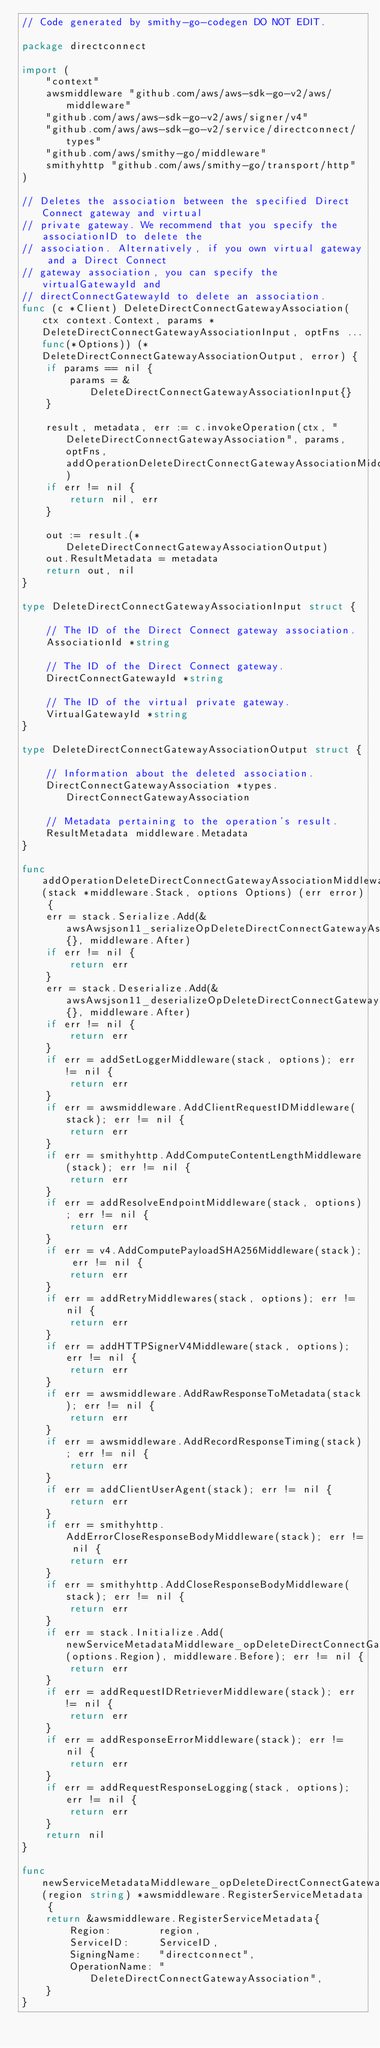Convert code to text. <code><loc_0><loc_0><loc_500><loc_500><_Go_>// Code generated by smithy-go-codegen DO NOT EDIT.

package directconnect

import (
	"context"
	awsmiddleware "github.com/aws/aws-sdk-go-v2/aws/middleware"
	"github.com/aws/aws-sdk-go-v2/aws/signer/v4"
	"github.com/aws/aws-sdk-go-v2/service/directconnect/types"
	"github.com/aws/smithy-go/middleware"
	smithyhttp "github.com/aws/smithy-go/transport/http"
)

// Deletes the association between the specified Direct Connect gateway and virtual
// private gateway. We recommend that you specify the associationID to delete the
// association. Alternatively, if you own virtual gateway and a Direct Connect
// gateway association, you can specify the virtualGatewayId and
// directConnectGatewayId to delete an association.
func (c *Client) DeleteDirectConnectGatewayAssociation(ctx context.Context, params *DeleteDirectConnectGatewayAssociationInput, optFns ...func(*Options)) (*DeleteDirectConnectGatewayAssociationOutput, error) {
	if params == nil {
		params = &DeleteDirectConnectGatewayAssociationInput{}
	}

	result, metadata, err := c.invokeOperation(ctx, "DeleteDirectConnectGatewayAssociation", params, optFns, addOperationDeleteDirectConnectGatewayAssociationMiddlewares)
	if err != nil {
		return nil, err
	}

	out := result.(*DeleteDirectConnectGatewayAssociationOutput)
	out.ResultMetadata = metadata
	return out, nil
}

type DeleteDirectConnectGatewayAssociationInput struct {

	// The ID of the Direct Connect gateway association.
	AssociationId *string

	// The ID of the Direct Connect gateway.
	DirectConnectGatewayId *string

	// The ID of the virtual private gateway.
	VirtualGatewayId *string
}

type DeleteDirectConnectGatewayAssociationOutput struct {

	// Information about the deleted association.
	DirectConnectGatewayAssociation *types.DirectConnectGatewayAssociation

	// Metadata pertaining to the operation's result.
	ResultMetadata middleware.Metadata
}

func addOperationDeleteDirectConnectGatewayAssociationMiddlewares(stack *middleware.Stack, options Options) (err error) {
	err = stack.Serialize.Add(&awsAwsjson11_serializeOpDeleteDirectConnectGatewayAssociation{}, middleware.After)
	if err != nil {
		return err
	}
	err = stack.Deserialize.Add(&awsAwsjson11_deserializeOpDeleteDirectConnectGatewayAssociation{}, middleware.After)
	if err != nil {
		return err
	}
	if err = addSetLoggerMiddleware(stack, options); err != nil {
		return err
	}
	if err = awsmiddleware.AddClientRequestIDMiddleware(stack); err != nil {
		return err
	}
	if err = smithyhttp.AddComputeContentLengthMiddleware(stack); err != nil {
		return err
	}
	if err = addResolveEndpointMiddleware(stack, options); err != nil {
		return err
	}
	if err = v4.AddComputePayloadSHA256Middleware(stack); err != nil {
		return err
	}
	if err = addRetryMiddlewares(stack, options); err != nil {
		return err
	}
	if err = addHTTPSignerV4Middleware(stack, options); err != nil {
		return err
	}
	if err = awsmiddleware.AddRawResponseToMetadata(stack); err != nil {
		return err
	}
	if err = awsmiddleware.AddRecordResponseTiming(stack); err != nil {
		return err
	}
	if err = addClientUserAgent(stack); err != nil {
		return err
	}
	if err = smithyhttp.AddErrorCloseResponseBodyMiddleware(stack); err != nil {
		return err
	}
	if err = smithyhttp.AddCloseResponseBodyMiddleware(stack); err != nil {
		return err
	}
	if err = stack.Initialize.Add(newServiceMetadataMiddleware_opDeleteDirectConnectGatewayAssociation(options.Region), middleware.Before); err != nil {
		return err
	}
	if err = addRequestIDRetrieverMiddleware(stack); err != nil {
		return err
	}
	if err = addResponseErrorMiddleware(stack); err != nil {
		return err
	}
	if err = addRequestResponseLogging(stack, options); err != nil {
		return err
	}
	return nil
}

func newServiceMetadataMiddleware_opDeleteDirectConnectGatewayAssociation(region string) *awsmiddleware.RegisterServiceMetadata {
	return &awsmiddleware.RegisterServiceMetadata{
		Region:        region,
		ServiceID:     ServiceID,
		SigningName:   "directconnect",
		OperationName: "DeleteDirectConnectGatewayAssociation",
	}
}
</code> 